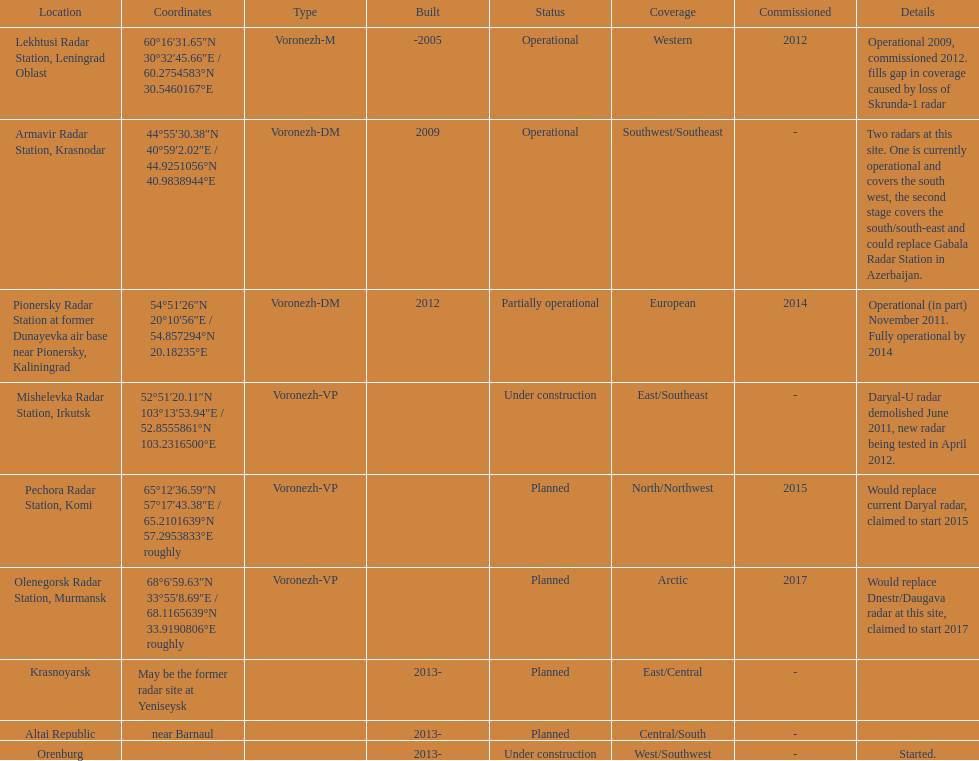How long did it take the pionersky radar station to go from partially operational to fully operational? 3 years. 